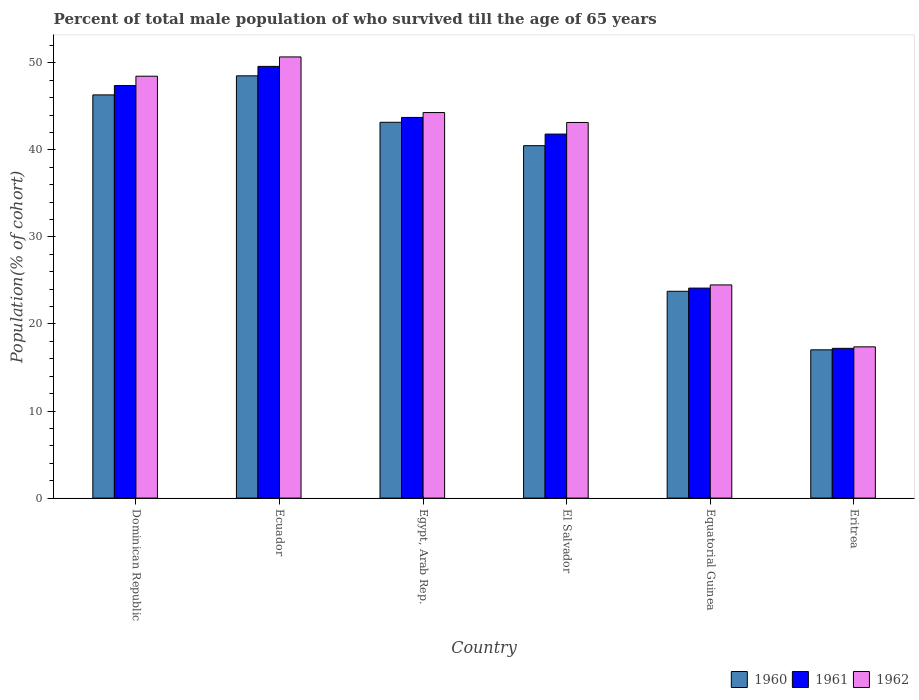How many different coloured bars are there?
Provide a short and direct response. 3. How many groups of bars are there?
Your answer should be compact. 6. How many bars are there on the 2nd tick from the left?
Make the answer very short. 3. How many bars are there on the 4th tick from the right?
Provide a succinct answer. 3. What is the label of the 1st group of bars from the left?
Give a very brief answer. Dominican Republic. What is the percentage of total male population who survived till the age of 65 years in 1960 in Egypt, Arab Rep.?
Your answer should be compact. 43.17. Across all countries, what is the maximum percentage of total male population who survived till the age of 65 years in 1961?
Make the answer very short. 49.59. Across all countries, what is the minimum percentage of total male population who survived till the age of 65 years in 1960?
Ensure brevity in your answer.  17.03. In which country was the percentage of total male population who survived till the age of 65 years in 1961 maximum?
Provide a short and direct response. Ecuador. In which country was the percentage of total male population who survived till the age of 65 years in 1961 minimum?
Keep it short and to the point. Eritrea. What is the total percentage of total male population who survived till the age of 65 years in 1960 in the graph?
Ensure brevity in your answer.  219.26. What is the difference between the percentage of total male population who survived till the age of 65 years in 1962 in Dominican Republic and that in Equatorial Guinea?
Make the answer very short. 23.97. What is the difference between the percentage of total male population who survived till the age of 65 years in 1962 in Eritrea and the percentage of total male population who survived till the age of 65 years in 1960 in Egypt, Arab Rep.?
Provide a succinct answer. -25.8. What is the average percentage of total male population who survived till the age of 65 years in 1961 per country?
Your response must be concise. 37.31. What is the difference between the percentage of total male population who survived till the age of 65 years of/in 1961 and percentage of total male population who survived till the age of 65 years of/in 1960 in Equatorial Guinea?
Make the answer very short. 0.36. What is the ratio of the percentage of total male population who survived till the age of 65 years in 1962 in Egypt, Arab Rep. to that in Equatorial Guinea?
Offer a terse response. 1.81. Is the difference between the percentage of total male population who survived till the age of 65 years in 1961 in Equatorial Guinea and Eritrea greater than the difference between the percentage of total male population who survived till the age of 65 years in 1960 in Equatorial Guinea and Eritrea?
Your answer should be very brief. Yes. What is the difference between the highest and the second highest percentage of total male population who survived till the age of 65 years in 1962?
Provide a succinct answer. -2.21. What is the difference between the highest and the lowest percentage of total male population who survived till the age of 65 years in 1962?
Give a very brief answer. 33.3. Is it the case that in every country, the sum of the percentage of total male population who survived till the age of 65 years in 1961 and percentage of total male population who survived till the age of 65 years in 1960 is greater than the percentage of total male population who survived till the age of 65 years in 1962?
Offer a terse response. Yes. Are all the bars in the graph horizontal?
Your answer should be compact. No. What is the difference between two consecutive major ticks on the Y-axis?
Your answer should be compact. 10. Does the graph contain any zero values?
Make the answer very short. No. Where does the legend appear in the graph?
Offer a terse response. Bottom right. What is the title of the graph?
Ensure brevity in your answer.  Percent of total male population of who survived till the age of 65 years. What is the label or title of the X-axis?
Provide a short and direct response. Country. What is the label or title of the Y-axis?
Provide a succinct answer. Population(% of cohort). What is the Population(% of cohort) of 1960 in Dominican Republic?
Your answer should be very brief. 46.32. What is the Population(% of cohort) in 1961 in Dominican Republic?
Provide a succinct answer. 47.39. What is the Population(% of cohort) of 1962 in Dominican Republic?
Keep it short and to the point. 48.46. What is the Population(% of cohort) of 1960 in Ecuador?
Your response must be concise. 48.51. What is the Population(% of cohort) in 1961 in Ecuador?
Your answer should be compact. 49.59. What is the Population(% of cohort) in 1962 in Ecuador?
Keep it short and to the point. 50.68. What is the Population(% of cohort) of 1960 in Egypt, Arab Rep.?
Make the answer very short. 43.17. What is the Population(% of cohort) in 1961 in Egypt, Arab Rep.?
Offer a very short reply. 43.73. What is the Population(% of cohort) of 1962 in Egypt, Arab Rep.?
Provide a short and direct response. 44.29. What is the Population(% of cohort) in 1960 in El Salvador?
Offer a terse response. 40.48. What is the Population(% of cohort) of 1961 in El Salvador?
Provide a succinct answer. 41.82. What is the Population(% of cohort) in 1962 in El Salvador?
Your answer should be very brief. 43.15. What is the Population(% of cohort) in 1960 in Equatorial Guinea?
Offer a terse response. 23.76. What is the Population(% of cohort) of 1961 in Equatorial Guinea?
Your answer should be very brief. 24.12. What is the Population(% of cohort) in 1962 in Equatorial Guinea?
Your answer should be very brief. 24.49. What is the Population(% of cohort) of 1960 in Eritrea?
Your response must be concise. 17.03. What is the Population(% of cohort) of 1961 in Eritrea?
Make the answer very short. 17.2. What is the Population(% of cohort) of 1962 in Eritrea?
Make the answer very short. 17.37. Across all countries, what is the maximum Population(% of cohort) in 1960?
Keep it short and to the point. 48.51. Across all countries, what is the maximum Population(% of cohort) of 1961?
Your response must be concise. 49.59. Across all countries, what is the maximum Population(% of cohort) of 1962?
Ensure brevity in your answer.  50.68. Across all countries, what is the minimum Population(% of cohort) in 1960?
Give a very brief answer. 17.03. Across all countries, what is the minimum Population(% of cohort) of 1961?
Give a very brief answer. 17.2. Across all countries, what is the minimum Population(% of cohort) of 1962?
Provide a short and direct response. 17.37. What is the total Population(% of cohort) in 1960 in the graph?
Keep it short and to the point. 219.26. What is the total Population(% of cohort) of 1961 in the graph?
Make the answer very short. 223.85. What is the total Population(% of cohort) in 1962 in the graph?
Provide a short and direct response. 228.43. What is the difference between the Population(% of cohort) in 1960 in Dominican Republic and that in Ecuador?
Provide a short and direct response. -2.19. What is the difference between the Population(% of cohort) of 1961 in Dominican Republic and that in Ecuador?
Your answer should be compact. -2.2. What is the difference between the Population(% of cohort) in 1962 in Dominican Republic and that in Ecuador?
Provide a succinct answer. -2.21. What is the difference between the Population(% of cohort) in 1960 in Dominican Republic and that in Egypt, Arab Rep.?
Provide a succinct answer. 3.15. What is the difference between the Population(% of cohort) in 1961 in Dominican Republic and that in Egypt, Arab Rep.?
Provide a succinct answer. 3.66. What is the difference between the Population(% of cohort) of 1962 in Dominican Republic and that in Egypt, Arab Rep.?
Keep it short and to the point. 4.18. What is the difference between the Population(% of cohort) of 1960 in Dominican Republic and that in El Salvador?
Offer a very short reply. 5.83. What is the difference between the Population(% of cohort) in 1961 in Dominican Republic and that in El Salvador?
Offer a terse response. 5.57. What is the difference between the Population(% of cohort) of 1962 in Dominican Republic and that in El Salvador?
Ensure brevity in your answer.  5.31. What is the difference between the Population(% of cohort) of 1960 in Dominican Republic and that in Equatorial Guinea?
Offer a very short reply. 22.56. What is the difference between the Population(% of cohort) in 1961 in Dominican Republic and that in Equatorial Guinea?
Give a very brief answer. 23.27. What is the difference between the Population(% of cohort) of 1962 in Dominican Republic and that in Equatorial Guinea?
Give a very brief answer. 23.97. What is the difference between the Population(% of cohort) in 1960 in Dominican Republic and that in Eritrea?
Make the answer very short. 29.28. What is the difference between the Population(% of cohort) of 1961 in Dominican Republic and that in Eritrea?
Give a very brief answer. 30.19. What is the difference between the Population(% of cohort) in 1962 in Dominican Republic and that in Eritrea?
Your answer should be compact. 31.09. What is the difference between the Population(% of cohort) in 1960 in Ecuador and that in Egypt, Arab Rep.?
Your answer should be compact. 5.34. What is the difference between the Population(% of cohort) of 1961 in Ecuador and that in Egypt, Arab Rep.?
Your answer should be compact. 5.86. What is the difference between the Population(% of cohort) of 1962 in Ecuador and that in Egypt, Arab Rep.?
Offer a terse response. 6.39. What is the difference between the Population(% of cohort) in 1960 in Ecuador and that in El Salvador?
Give a very brief answer. 8.02. What is the difference between the Population(% of cohort) in 1961 in Ecuador and that in El Salvador?
Make the answer very short. 7.78. What is the difference between the Population(% of cohort) of 1962 in Ecuador and that in El Salvador?
Offer a very short reply. 7.53. What is the difference between the Population(% of cohort) in 1960 in Ecuador and that in Equatorial Guinea?
Give a very brief answer. 24.75. What is the difference between the Population(% of cohort) in 1961 in Ecuador and that in Equatorial Guinea?
Give a very brief answer. 25.47. What is the difference between the Population(% of cohort) of 1962 in Ecuador and that in Equatorial Guinea?
Your answer should be compact. 26.19. What is the difference between the Population(% of cohort) in 1960 in Ecuador and that in Eritrea?
Give a very brief answer. 31.47. What is the difference between the Population(% of cohort) in 1961 in Ecuador and that in Eritrea?
Your answer should be very brief. 32.39. What is the difference between the Population(% of cohort) of 1962 in Ecuador and that in Eritrea?
Keep it short and to the point. 33.3. What is the difference between the Population(% of cohort) in 1960 in Egypt, Arab Rep. and that in El Salvador?
Provide a short and direct response. 2.69. What is the difference between the Population(% of cohort) in 1961 in Egypt, Arab Rep. and that in El Salvador?
Keep it short and to the point. 1.91. What is the difference between the Population(% of cohort) in 1962 in Egypt, Arab Rep. and that in El Salvador?
Ensure brevity in your answer.  1.14. What is the difference between the Population(% of cohort) in 1960 in Egypt, Arab Rep. and that in Equatorial Guinea?
Provide a short and direct response. 19.41. What is the difference between the Population(% of cohort) of 1961 in Egypt, Arab Rep. and that in Equatorial Guinea?
Give a very brief answer. 19.61. What is the difference between the Population(% of cohort) in 1962 in Egypt, Arab Rep. and that in Equatorial Guinea?
Give a very brief answer. 19.8. What is the difference between the Population(% of cohort) in 1960 in Egypt, Arab Rep. and that in Eritrea?
Make the answer very short. 26.14. What is the difference between the Population(% of cohort) of 1961 in Egypt, Arab Rep. and that in Eritrea?
Ensure brevity in your answer.  26.53. What is the difference between the Population(% of cohort) of 1962 in Egypt, Arab Rep. and that in Eritrea?
Offer a very short reply. 26.91. What is the difference between the Population(% of cohort) of 1960 in El Salvador and that in Equatorial Guinea?
Your answer should be very brief. 16.72. What is the difference between the Population(% of cohort) in 1961 in El Salvador and that in Equatorial Guinea?
Keep it short and to the point. 17.69. What is the difference between the Population(% of cohort) of 1962 in El Salvador and that in Equatorial Guinea?
Offer a terse response. 18.66. What is the difference between the Population(% of cohort) in 1960 in El Salvador and that in Eritrea?
Provide a succinct answer. 23.45. What is the difference between the Population(% of cohort) in 1961 in El Salvador and that in Eritrea?
Give a very brief answer. 24.61. What is the difference between the Population(% of cohort) of 1962 in El Salvador and that in Eritrea?
Your response must be concise. 25.78. What is the difference between the Population(% of cohort) in 1960 in Equatorial Guinea and that in Eritrea?
Give a very brief answer. 6.73. What is the difference between the Population(% of cohort) in 1961 in Equatorial Guinea and that in Eritrea?
Provide a succinct answer. 6.92. What is the difference between the Population(% of cohort) of 1962 in Equatorial Guinea and that in Eritrea?
Ensure brevity in your answer.  7.11. What is the difference between the Population(% of cohort) in 1960 in Dominican Republic and the Population(% of cohort) in 1961 in Ecuador?
Give a very brief answer. -3.27. What is the difference between the Population(% of cohort) in 1960 in Dominican Republic and the Population(% of cohort) in 1962 in Ecuador?
Provide a short and direct response. -4.36. What is the difference between the Population(% of cohort) of 1961 in Dominican Republic and the Population(% of cohort) of 1962 in Ecuador?
Your response must be concise. -3.29. What is the difference between the Population(% of cohort) of 1960 in Dominican Republic and the Population(% of cohort) of 1961 in Egypt, Arab Rep.?
Offer a very short reply. 2.59. What is the difference between the Population(% of cohort) in 1960 in Dominican Republic and the Population(% of cohort) in 1962 in Egypt, Arab Rep.?
Your response must be concise. 2.03. What is the difference between the Population(% of cohort) of 1961 in Dominican Republic and the Population(% of cohort) of 1962 in Egypt, Arab Rep.?
Offer a very short reply. 3.1. What is the difference between the Population(% of cohort) in 1960 in Dominican Republic and the Population(% of cohort) in 1961 in El Salvador?
Offer a terse response. 4.5. What is the difference between the Population(% of cohort) in 1960 in Dominican Republic and the Population(% of cohort) in 1962 in El Salvador?
Give a very brief answer. 3.17. What is the difference between the Population(% of cohort) of 1961 in Dominican Republic and the Population(% of cohort) of 1962 in El Salvador?
Your answer should be very brief. 4.24. What is the difference between the Population(% of cohort) in 1960 in Dominican Republic and the Population(% of cohort) in 1961 in Equatorial Guinea?
Your answer should be very brief. 22.19. What is the difference between the Population(% of cohort) in 1960 in Dominican Republic and the Population(% of cohort) in 1962 in Equatorial Guinea?
Offer a terse response. 21.83. What is the difference between the Population(% of cohort) in 1961 in Dominican Republic and the Population(% of cohort) in 1962 in Equatorial Guinea?
Your answer should be very brief. 22.9. What is the difference between the Population(% of cohort) in 1960 in Dominican Republic and the Population(% of cohort) in 1961 in Eritrea?
Your answer should be very brief. 29.11. What is the difference between the Population(% of cohort) of 1960 in Dominican Republic and the Population(% of cohort) of 1962 in Eritrea?
Ensure brevity in your answer.  28.94. What is the difference between the Population(% of cohort) of 1961 in Dominican Republic and the Population(% of cohort) of 1962 in Eritrea?
Offer a terse response. 30.02. What is the difference between the Population(% of cohort) in 1960 in Ecuador and the Population(% of cohort) in 1961 in Egypt, Arab Rep.?
Your answer should be compact. 4.78. What is the difference between the Population(% of cohort) of 1960 in Ecuador and the Population(% of cohort) of 1962 in Egypt, Arab Rep.?
Your answer should be compact. 4.22. What is the difference between the Population(% of cohort) of 1961 in Ecuador and the Population(% of cohort) of 1962 in Egypt, Arab Rep.?
Provide a short and direct response. 5.3. What is the difference between the Population(% of cohort) in 1960 in Ecuador and the Population(% of cohort) in 1961 in El Salvador?
Make the answer very short. 6.69. What is the difference between the Population(% of cohort) in 1960 in Ecuador and the Population(% of cohort) in 1962 in El Salvador?
Your response must be concise. 5.36. What is the difference between the Population(% of cohort) of 1961 in Ecuador and the Population(% of cohort) of 1962 in El Salvador?
Offer a very short reply. 6.44. What is the difference between the Population(% of cohort) of 1960 in Ecuador and the Population(% of cohort) of 1961 in Equatorial Guinea?
Provide a short and direct response. 24.38. What is the difference between the Population(% of cohort) in 1960 in Ecuador and the Population(% of cohort) in 1962 in Equatorial Guinea?
Your answer should be very brief. 24.02. What is the difference between the Population(% of cohort) in 1961 in Ecuador and the Population(% of cohort) in 1962 in Equatorial Guinea?
Ensure brevity in your answer.  25.1. What is the difference between the Population(% of cohort) of 1960 in Ecuador and the Population(% of cohort) of 1961 in Eritrea?
Provide a succinct answer. 31.3. What is the difference between the Population(% of cohort) of 1960 in Ecuador and the Population(% of cohort) of 1962 in Eritrea?
Your response must be concise. 31.13. What is the difference between the Population(% of cohort) of 1961 in Ecuador and the Population(% of cohort) of 1962 in Eritrea?
Keep it short and to the point. 32.22. What is the difference between the Population(% of cohort) of 1960 in Egypt, Arab Rep. and the Population(% of cohort) of 1961 in El Salvador?
Provide a short and direct response. 1.35. What is the difference between the Population(% of cohort) in 1960 in Egypt, Arab Rep. and the Population(% of cohort) in 1962 in El Salvador?
Offer a terse response. 0.02. What is the difference between the Population(% of cohort) of 1961 in Egypt, Arab Rep. and the Population(% of cohort) of 1962 in El Salvador?
Your response must be concise. 0.58. What is the difference between the Population(% of cohort) in 1960 in Egypt, Arab Rep. and the Population(% of cohort) in 1961 in Equatorial Guinea?
Ensure brevity in your answer.  19.05. What is the difference between the Population(% of cohort) in 1960 in Egypt, Arab Rep. and the Population(% of cohort) in 1962 in Equatorial Guinea?
Provide a short and direct response. 18.68. What is the difference between the Population(% of cohort) in 1961 in Egypt, Arab Rep. and the Population(% of cohort) in 1962 in Equatorial Guinea?
Offer a very short reply. 19.24. What is the difference between the Population(% of cohort) of 1960 in Egypt, Arab Rep. and the Population(% of cohort) of 1961 in Eritrea?
Provide a short and direct response. 25.97. What is the difference between the Population(% of cohort) of 1960 in Egypt, Arab Rep. and the Population(% of cohort) of 1962 in Eritrea?
Ensure brevity in your answer.  25.8. What is the difference between the Population(% of cohort) in 1961 in Egypt, Arab Rep. and the Population(% of cohort) in 1962 in Eritrea?
Your response must be concise. 26.36. What is the difference between the Population(% of cohort) in 1960 in El Salvador and the Population(% of cohort) in 1961 in Equatorial Guinea?
Provide a succinct answer. 16.36. What is the difference between the Population(% of cohort) of 1960 in El Salvador and the Population(% of cohort) of 1962 in Equatorial Guinea?
Offer a very short reply. 15.99. What is the difference between the Population(% of cohort) in 1961 in El Salvador and the Population(% of cohort) in 1962 in Equatorial Guinea?
Make the answer very short. 17.33. What is the difference between the Population(% of cohort) of 1960 in El Salvador and the Population(% of cohort) of 1961 in Eritrea?
Offer a very short reply. 23.28. What is the difference between the Population(% of cohort) of 1960 in El Salvador and the Population(% of cohort) of 1962 in Eritrea?
Offer a terse response. 23.11. What is the difference between the Population(% of cohort) in 1961 in El Salvador and the Population(% of cohort) in 1962 in Eritrea?
Give a very brief answer. 24.44. What is the difference between the Population(% of cohort) of 1960 in Equatorial Guinea and the Population(% of cohort) of 1961 in Eritrea?
Provide a succinct answer. 6.56. What is the difference between the Population(% of cohort) of 1960 in Equatorial Guinea and the Population(% of cohort) of 1962 in Eritrea?
Give a very brief answer. 6.39. What is the difference between the Population(% of cohort) of 1961 in Equatorial Guinea and the Population(% of cohort) of 1962 in Eritrea?
Provide a succinct answer. 6.75. What is the average Population(% of cohort) of 1960 per country?
Your answer should be compact. 36.54. What is the average Population(% of cohort) of 1961 per country?
Your answer should be compact. 37.31. What is the average Population(% of cohort) in 1962 per country?
Your response must be concise. 38.07. What is the difference between the Population(% of cohort) of 1960 and Population(% of cohort) of 1961 in Dominican Republic?
Offer a terse response. -1.07. What is the difference between the Population(% of cohort) of 1960 and Population(% of cohort) of 1962 in Dominican Republic?
Provide a succinct answer. -2.15. What is the difference between the Population(% of cohort) in 1961 and Population(% of cohort) in 1962 in Dominican Republic?
Make the answer very short. -1.07. What is the difference between the Population(% of cohort) of 1960 and Population(% of cohort) of 1961 in Ecuador?
Offer a very short reply. -1.09. What is the difference between the Population(% of cohort) of 1960 and Population(% of cohort) of 1962 in Ecuador?
Give a very brief answer. -2.17. What is the difference between the Population(% of cohort) in 1961 and Population(% of cohort) in 1962 in Ecuador?
Make the answer very short. -1.09. What is the difference between the Population(% of cohort) in 1960 and Population(% of cohort) in 1961 in Egypt, Arab Rep.?
Ensure brevity in your answer.  -0.56. What is the difference between the Population(% of cohort) of 1960 and Population(% of cohort) of 1962 in Egypt, Arab Rep.?
Provide a succinct answer. -1.12. What is the difference between the Population(% of cohort) in 1961 and Population(% of cohort) in 1962 in Egypt, Arab Rep.?
Make the answer very short. -0.56. What is the difference between the Population(% of cohort) in 1960 and Population(% of cohort) in 1961 in El Salvador?
Provide a short and direct response. -1.33. What is the difference between the Population(% of cohort) of 1960 and Population(% of cohort) of 1962 in El Salvador?
Give a very brief answer. -2.67. What is the difference between the Population(% of cohort) in 1961 and Population(% of cohort) in 1962 in El Salvador?
Your answer should be very brief. -1.33. What is the difference between the Population(% of cohort) of 1960 and Population(% of cohort) of 1961 in Equatorial Guinea?
Offer a very short reply. -0.36. What is the difference between the Population(% of cohort) of 1960 and Population(% of cohort) of 1962 in Equatorial Guinea?
Offer a very short reply. -0.73. What is the difference between the Population(% of cohort) in 1961 and Population(% of cohort) in 1962 in Equatorial Guinea?
Your response must be concise. -0.36. What is the difference between the Population(% of cohort) in 1960 and Population(% of cohort) in 1961 in Eritrea?
Give a very brief answer. -0.17. What is the difference between the Population(% of cohort) in 1960 and Population(% of cohort) in 1962 in Eritrea?
Keep it short and to the point. -0.34. What is the difference between the Population(% of cohort) of 1961 and Population(% of cohort) of 1962 in Eritrea?
Offer a very short reply. -0.17. What is the ratio of the Population(% of cohort) of 1960 in Dominican Republic to that in Ecuador?
Keep it short and to the point. 0.95. What is the ratio of the Population(% of cohort) of 1961 in Dominican Republic to that in Ecuador?
Make the answer very short. 0.96. What is the ratio of the Population(% of cohort) in 1962 in Dominican Republic to that in Ecuador?
Offer a very short reply. 0.96. What is the ratio of the Population(% of cohort) in 1960 in Dominican Republic to that in Egypt, Arab Rep.?
Your answer should be very brief. 1.07. What is the ratio of the Population(% of cohort) of 1961 in Dominican Republic to that in Egypt, Arab Rep.?
Provide a succinct answer. 1.08. What is the ratio of the Population(% of cohort) in 1962 in Dominican Republic to that in Egypt, Arab Rep.?
Offer a terse response. 1.09. What is the ratio of the Population(% of cohort) in 1960 in Dominican Republic to that in El Salvador?
Provide a short and direct response. 1.14. What is the ratio of the Population(% of cohort) of 1961 in Dominican Republic to that in El Salvador?
Provide a succinct answer. 1.13. What is the ratio of the Population(% of cohort) in 1962 in Dominican Republic to that in El Salvador?
Your answer should be compact. 1.12. What is the ratio of the Population(% of cohort) in 1960 in Dominican Republic to that in Equatorial Guinea?
Offer a very short reply. 1.95. What is the ratio of the Population(% of cohort) of 1961 in Dominican Republic to that in Equatorial Guinea?
Keep it short and to the point. 1.96. What is the ratio of the Population(% of cohort) of 1962 in Dominican Republic to that in Equatorial Guinea?
Your response must be concise. 1.98. What is the ratio of the Population(% of cohort) of 1960 in Dominican Republic to that in Eritrea?
Provide a short and direct response. 2.72. What is the ratio of the Population(% of cohort) of 1961 in Dominican Republic to that in Eritrea?
Your answer should be very brief. 2.75. What is the ratio of the Population(% of cohort) of 1962 in Dominican Republic to that in Eritrea?
Offer a very short reply. 2.79. What is the ratio of the Population(% of cohort) in 1960 in Ecuador to that in Egypt, Arab Rep.?
Provide a short and direct response. 1.12. What is the ratio of the Population(% of cohort) of 1961 in Ecuador to that in Egypt, Arab Rep.?
Your answer should be very brief. 1.13. What is the ratio of the Population(% of cohort) of 1962 in Ecuador to that in Egypt, Arab Rep.?
Give a very brief answer. 1.14. What is the ratio of the Population(% of cohort) in 1960 in Ecuador to that in El Salvador?
Provide a short and direct response. 1.2. What is the ratio of the Population(% of cohort) of 1961 in Ecuador to that in El Salvador?
Provide a short and direct response. 1.19. What is the ratio of the Population(% of cohort) of 1962 in Ecuador to that in El Salvador?
Offer a very short reply. 1.17. What is the ratio of the Population(% of cohort) in 1960 in Ecuador to that in Equatorial Guinea?
Your answer should be very brief. 2.04. What is the ratio of the Population(% of cohort) in 1961 in Ecuador to that in Equatorial Guinea?
Keep it short and to the point. 2.06. What is the ratio of the Population(% of cohort) in 1962 in Ecuador to that in Equatorial Guinea?
Provide a succinct answer. 2.07. What is the ratio of the Population(% of cohort) of 1960 in Ecuador to that in Eritrea?
Provide a succinct answer. 2.85. What is the ratio of the Population(% of cohort) in 1961 in Ecuador to that in Eritrea?
Give a very brief answer. 2.88. What is the ratio of the Population(% of cohort) in 1962 in Ecuador to that in Eritrea?
Your answer should be very brief. 2.92. What is the ratio of the Population(% of cohort) of 1960 in Egypt, Arab Rep. to that in El Salvador?
Your response must be concise. 1.07. What is the ratio of the Population(% of cohort) in 1961 in Egypt, Arab Rep. to that in El Salvador?
Offer a terse response. 1.05. What is the ratio of the Population(% of cohort) of 1962 in Egypt, Arab Rep. to that in El Salvador?
Offer a very short reply. 1.03. What is the ratio of the Population(% of cohort) in 1960 in Egypt, Arab Rep. to that in Equatorial Guinea?
Ensure brevity in your answer.  1.82. What is the ratio of the Population(% of cohort) in 1961 in Egypt, Arab Rep. to that in Equatorial Guinea?
Provide a short and direct response. 1.81. What is the ratio of the Population(% of cohort) of 1962 in Egypt, Arab Rep. to that in Equatorial Guinea?
Offer a very short reply. 1.81. What is the ratio of the Population(% of cohort) in 1960 in Egypt, Arab Rep. to that in Eritrea?
Your response must be concise. 2.53. What is the ratio of the Population(% of cohort) of 1961 in Egypt, Arab Rep. to that in Eritrea?
Ensure brevity in your answer.  2.54. What is the ratio of the Population(% of cohort) in 1962 in Egypt, Arab Rep. to that in Eritrea?
Keep it short and to the point. 2.55. What is the ratio of the Population(% of cohort) in 1960 in El Salvador to that in Equatorial Guinea?
Your answer should be compact. 1.7. What is the ratio of the Population(% of cohort) in 1961 in El Salvador to that in Equatorial Guinea?
Your answer should be very brief. 1.73. What is the ratio of the Population(% of cohort) in 1962 in El Salvador to that in Equatorial Guinea?
Give a very brief answer. 1.76. What is the ratio of the Population(% of cohort) in 1960 in El Salvador to that in Eritrea?
Your answer should be compact. 2.38. What is the ratio of the Population(% of cohort) of 1961 in El Salvador to that in Eritrea?
Make the answer very short. 2.43. What is the ratio of the Population(% of cohort) in 1962 in El Salvador to that in Eritrea?
Provide a short and direct response. 2.48. What is the ratio of the Population(% of cohort) in 1960 in Equatorial Guinea to that in Eritrea?
Make the answer very short. 1.39. What is the ratio of the Population(% of cohort) in 1961 in Equatorial Guinea to that in Eritrea?
Provide a succinct answer. 1.4. What is the ratio of the Population(% of cohort) of 1962 in Equatorial Guinea to that in Eritrea?
Give a very brief answer. 1.41. What is the difference between the highest and the second highest Population(% of cohort) of 1960?
Give a very brief answer. 2.19. What is the difference between the highest and the second highest Population(% of cohort) in 1961?
Offer a terse response. 2.2. What is the difference between the highest and the second highest Population(% of cohort) of 1962?
Make the answer very short. 2.21. What is the difference between the highest and the lowest Population(% of cohort) of 1960?
Your answer should be very brief. 31.47. What is the difference between the highest and the lowest Population(% of cohort) of 1961?
Offer a terse response. 32.39. What is the difference between the highest and the lowest Population(% of cohort) of 1962?
Offer a very short reply. 33.3. 